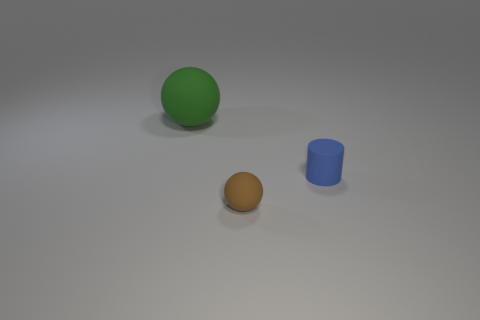What is the material of the object that is behind the brown sphere and to the left of the small blue object?
Keep it short and to the point. Rubber. Do the brown object and the matte object that is behind the blue matte object have the same shape?
Give a very brief answer. Yes. What is the material of the ball that is to the left of the sphere in front of the rubber sphere that is to the left of the small matte ball?
Provide a succinct answer. Rubber. How many other things are the same size as the brown rubber thing?
Offer a very short reply. 1. Do the rubber cylinder and the big sphere have the same color?
Your response must be concise. No. There is a matte ball that is in front of the rubber sphere left of the brown thing; how many large green objects are right of it?
Ensure brevity in your answer.  0. What is the material of the tiny thing on the right side of the tiny rubber object that is in front of the blue object?
Offer a very short reply. Rubber. Is there another big brown thing that has the same shape as the large object?
Your answer should be compact. No. There is another thing that is the same size as the blue matte object; what is its color?
Ensure brevity in your answer.  Brown. How many things are matte objects in front of the green rubber sphere or objects to the left of the small brown rubber object?
Offer a very short reply. 3. 